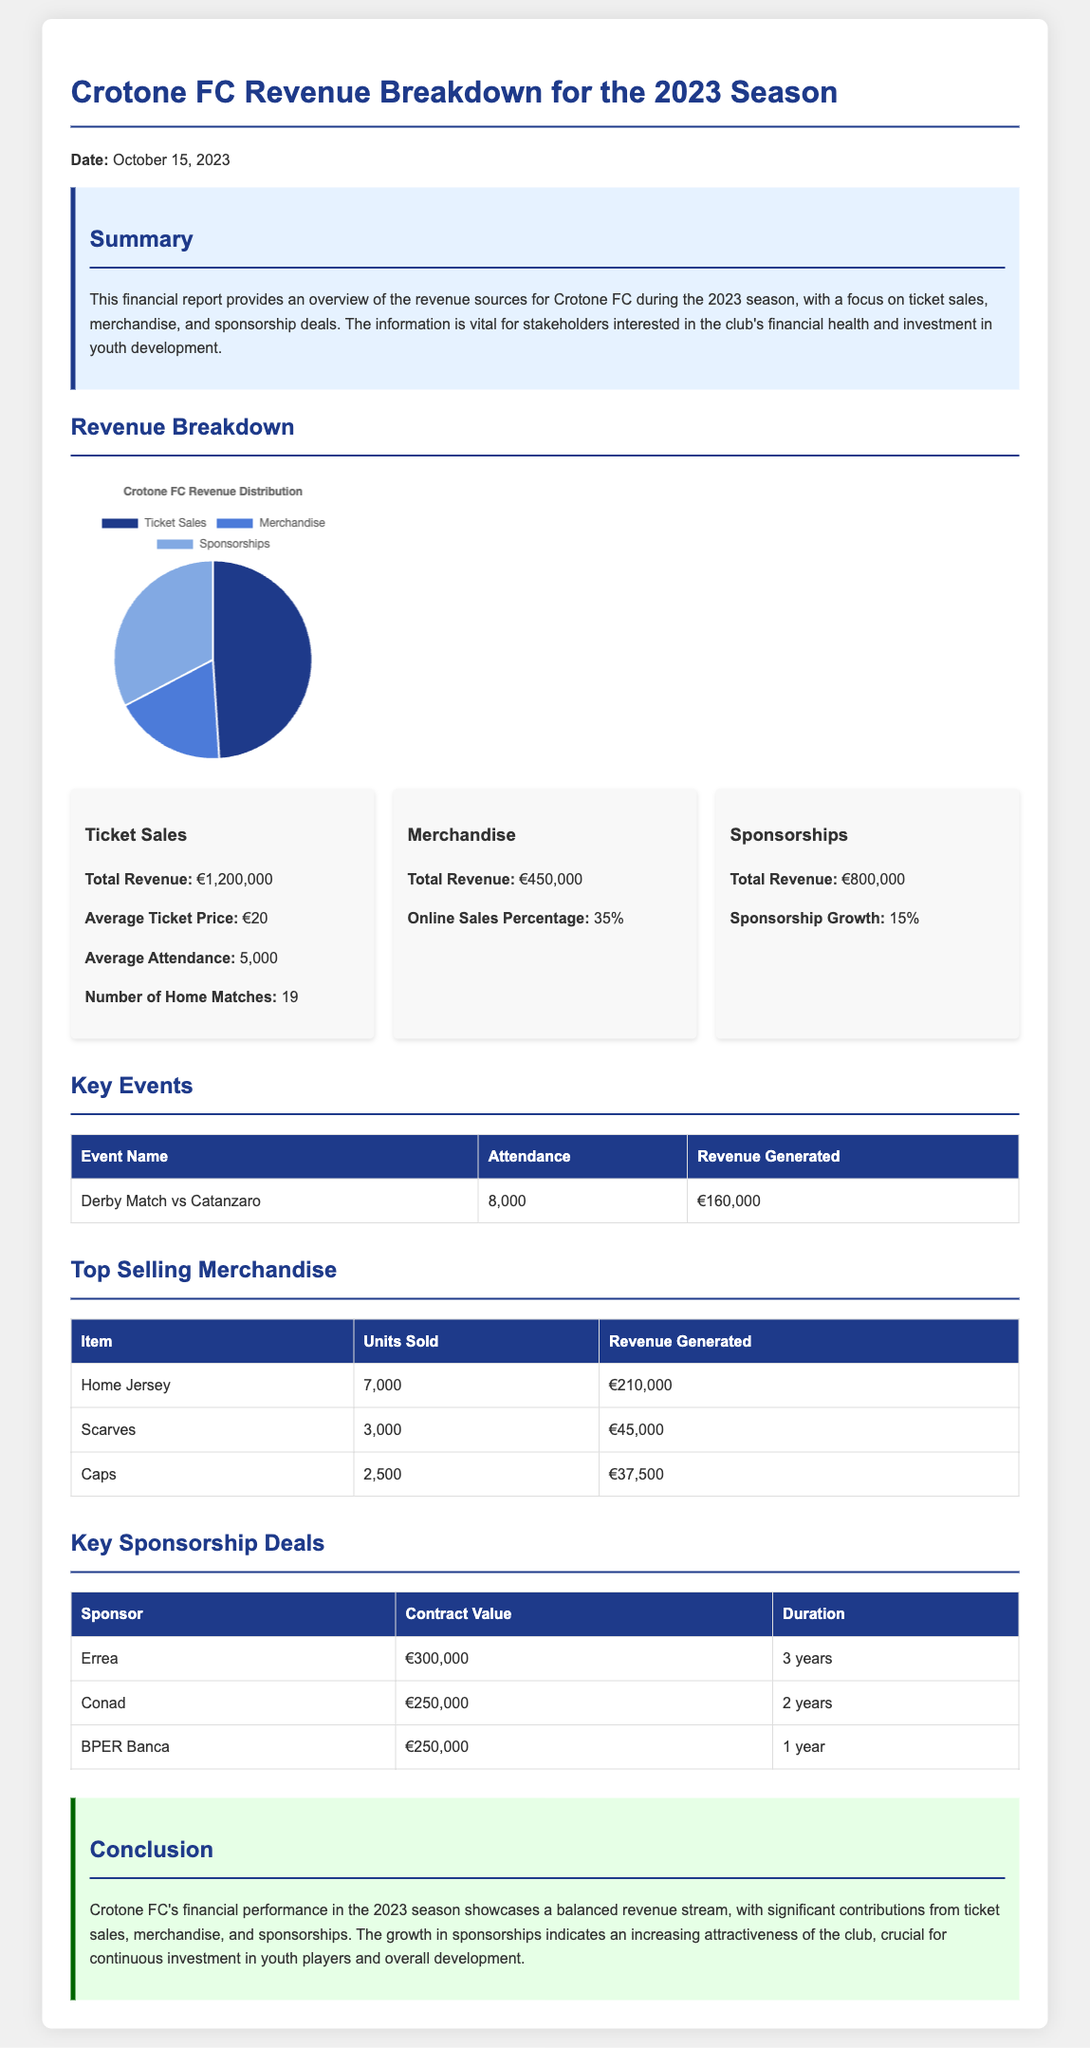What is the total revenue from ticket sales? The total revenue from ticket sales is clearly stated in the document.
Answer: €1,200,000 What is the average ticket price? The average ticket price is mentioned in the revenue section focused on ticket sales.
Answer: €20 What percentage of merchandise sales are online? The online sales percentage for merchandise is specified in the revenue breakdown.
Answer: 35% How much revenue was generated from sponsorships? The total revenue generated from sponsorships is provided in the report.
Answer: €800,000 What was the attendance at the derby match vs Catanzaro? The attendance for the derby match is presented in the key events section of the report.
Answer: 8,000 Which item generated the highest revenue in merchandise? The report lists the revenue generated by merchandise, identifying the top-selling item.
Answer: Home Jersey What was the contract value of Errea as a sponsor? The financial report specifies the sponsorship deals, including the value for Errea.
Answer: €300,000 What is the growth percentage of sponsorships? The growth in sponsorship revenue is explicitly mentioned in the sponsorship section.
Answer: 15% How many home matches were played during the season? The number of home matches is included in the ticket sales details.
Answer: 19 